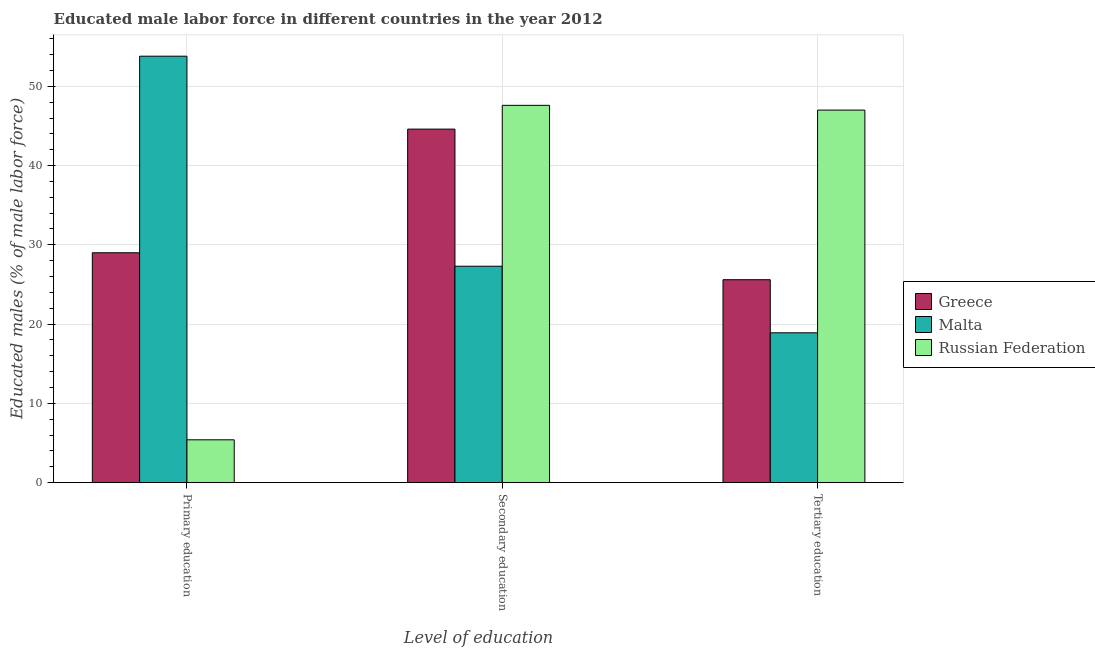How many different coloured bars are there?
Give a very brief answer. 3. How many groups of bars are there?
Keep it short and to the point. 3. How many bars are there on the 2nd tick from the right?
Ensure brevity in your answer.  3. What is the label of the 2nd group of bars from the left?
Ensure brevity in your answer.  Secondary education. What is the percentage of male labor force who received primary education in Russian Federation?
Offer a terse response. 5.4. Across all countries, what is the maximum percentage of male labor force who received primary education?
Make the answer very short. 53.8. Across all countries, what is the minimum percentage of male labor force who received tertiary education?
Ensure brevity in your answer.  18.9. In which country was the percentage of male labor force who received tertiary education maximum?
Ensure brevity in your answer.  Russian Federation. In which country was the percentage of male labor force who received tertiary education minimum?
Offer a terse response. Malta. What is the total percentage of male labor force who received secondary education in the graph?
Keep it short and to the point. 119.5. What is the difference between the percentage of male labor force who received secondary education in Greece and that in Malta?
Your answer should be compact. 17.3. What is the difference between the percentage of male labor force who received secondary education in Malta and the percentage of male labor force who received tertiary education in Russian Federation?
Your answer should be very brief. -19.7. What is the average percentage of male labor force who received secondary education per country?
Your answer should be very brief. 39.83. What is the difference between the percentage of male labor force who received secondary education and percentage of male labor force who received primary education in Russian Federation?
Offer a very short reply. 42.2. What is the ratio of the percentage of male labor force who received tertiary education in Malta to that in Russian Federation?
Give a very brief answer. 0.4. Is the percentage of male labor force who received secondary education in Malta less than that in Greece?
Provide a succinct answer. Yes. Is the difference between the percentage of male labor force who received tertiary education in Malta and Russian Federation greater than the difference between the percentage of male labor force who received secondary education in Malta and Russian Federation?
Offer a terse response. No. What is the difference between the highest and the second highest percentage of male labor force who received primary education?
Provide a succinct answer. 24.8. What is the difference between the highest and the lowest percentage of male labor force who received primary education?
Make the answer very short. 48.4. What does the 1st bar from the left in Tertiary education represents?
Your response must be concise. Greece. How many bars are there?
Give a very brief answer. 9. Are all the bars in the graph horizontal?
Ensure brevity in your answer.  No. What is the difference between two consecutive major ticks on the Y-axis?
Your response must be concise. 10. Does the graph contain any zero values?
Your response must be concise. No. Does the graph contain grids?
Your response must be concise. Yes. Where does the legend appear in the graph?
Your answer should be very brief. Center right. How many legend labels are there?
Provide a short and direct response. 3. What is the title of the graph?
Offer a terse response. Educated male labor force in different countries in the year 2012. Does "Mexico" appear as one of the legend labels in the graph?
Make the answer very short. No. What is the label or title of the X-axis?
Make the answer very short. Level of education. What is the label or title of the Y-axis?
Provide a succinct answer. Educated males (% of male labor force). What is the Educated males (% of male labor force) of Greece in Primary education?
Offer a terse response. 29. What is the Educated males (% of male labor force) in Malta in Primary education?
Your answer should be compact. 53.8. What is the Educated males (% of male labor force) of Russian Federation in Primary education?
Your answer should be compact. 5.4. What is the Educated males (% of male labor force) in Greece in Secondary education?
Keep it short and to the point. 44.6. What is the Educated males (% of male labor force) of Malta in Secondary education?
Offer a very short reply. 27.3. What is the Educated males (% of male labor force) in Russian Federation in Secondary education?
Offer a terse response. 47.6. What is the Educated males (% of male labor force) of Greece in Tertiary education?
Provide a succinct answer. 25.6. What is the Educated males (% of male labor force) in Malta in Tertiary education?
Offer a very short reply. 18.9. Across all Level of education, what is the maximum Educated males (% of male labor force) of Greece?
Keep it short and to the point. 44.6. Across all Level of education, what is the maximum Educated males (% of male labor force) of Malta?
Give a very brief answer. 53.8. Across all Level of education, what is the maximum Educated males (% of male labor force) in Russian Federation?
Ensure brevity in your answer.  47.6. Across all Level of education, what is the minimum Educated males (% of male labor force) in Greece?
Ensure brevity in your answer.  25.6. Across all Level of education, what is the minimum Educated males (% of male labor force) in Malta?
Offer a terse response. 18.9. Across all Level of education, what is the minimum Educated males (% of male labor force) in Russian Federation?
Provide a succinct answer. 5.4. What is the total Educated males (% of male labor force) of Greece in the graph?
Keep it short and to the point. 99.2. What is the difference between the Educated males (% of male labor force) of Greece in Primary education and that in Secondary education?
Ensure brevity in your answer.  -15.6. What is the difference between the Educated males (% of male labor force) of Russian Federation in Primary education and that in Secondary education?
Give a very brief answer. -42.2. What is the difference between the Educated males (% of male labor force) of Malta in Primary education and that in Tertiary education?
Offer a very short reply. 34.9. What is the difference between the Educated males (% of male labor force) of Russian Federation in Primary education and that in Tertiary education?
Keep it short and to the point. -41.6. What is the difference between the Educated males (% of male labor force) of Russian Federation in Secondary education and that in Tertiary education?
Offer a terse response. 0.6. What is the difference between the Educated males (% of male labor force) in Greece in Primary education and the Educated males (% of male labor force) in Malta in Secondary education?
Your answer should be compact. 1.7. What is the difference between the Educated males (% of male labor force) of Greece in Primary education and the Educated males (% of male labor force) of Russian Federation in Secondary education?
Your answer should be very brief. -18.6. What is the difference between the Educated males (% of male labor force) in Malta in Primary education and the Educated males (% of male labor force) in Russian Federation in Secondary education?
Your answer should be compact. 6.2. What is the difference between the Educated males (% of male labor force) of Greece in Primary education and the Educated males (% of male labor force) of Malta in Tertiary education?
Keep it short and to the point. 10.1. What is the difference between the Educated males (% of male labor force) of Greece in Secondary education and the Educated males (% of male labor force) of Malta in Tertiary education?
Make the answer very short. 25.7. What is the difference between the Educated males (% of male labor force) of Malta in Secondary education and the Educated males (% of male labor force) of Russian Federation in Tertiary education?
Provide a succinct answer. -19.7. What is the average Educated males (% of male labor force) of Greece per Level of education?
Ensure brevity in your answer.  33.07. What is the average Educated males (% of male labor force) in Malta per Level of education?
Your response must be concise. 33.33. What is the average Educated males (% of male labor force) in Russian Federation per Level of education?
Make the answer very short. 33.33. What is the difference between the Educated males (% of male labor force) in Greece and Educated males (% of male labor force) in Malta in Primary education?
Offer a terse response. -24.8. What is the difference between the Educated males (% of male labor force) in Greece and Educated males (% of male labor force) in Russian Federation in Primary education?
Provide a short and direct response. 23.6. What is the difference between the Educated males (% of male labor force) in Malta and Educated males (% of male labor force) in Russian Federation in Primary education?
Your answer should be very brief. 48.4. What is the difference between the Educated males (% of male labor force) of Malta and Educated males (% of male labor force) of Russian Federation in Secondary education?
Your answer should be compact. -20.3. What is the difference between the Educated males (% of male labor force) of Greece and Educated males (% of male labor force) of Malta in Tertiary education?
Make the answer very short. 6.7. What is the difference between the Educated males (% of male labor force) in Greece and Educated males (% of male labor force) in Russian Federation in Tertiary education?
Keep it short and to the point. -21.4. What is the difference between the Educated males (% of male labor force) of Malta and Educated males (% of male labor force) of Russian Federation in Tertiary education?
Ensure brevity in your answer.  -28.1. What is the ratio of the Educated males (% of male labor force) in Greece in Primary education to that in Secondary education?
Your answer should be very brief. 0.65. What is the ratio of the Educated males (% of male labor force) in Malta in Primary education to that in Secondary education?
Make the answer very short. 1.97. What is the ratio of the Educated males (% of male labor force) in Russian Federation in Primary education to that in Secondary education?
Your response must be concise. 0.11. What is the ratio of the Educated males (% of male labor force) in Greece in Primary education to that in Tertiary education?
Provide a short and direct response. 1.13. What is the ratio of the Educated males (% of male labor force) in Malta in Primary education to that in Tertiary education?
Offer a very short reply. 2.85. What is the ratio of the Educated males (% of male labor force) of Russian Federation in Primary education to that in Tertiary education?
Your answer should be very brief. 0.11. What is the ratio of the Educated males (% of male labor force) of Greece in Secondary education to that in Tertiary education?
Provide a succinct answer. 1.74. What is the ratio of the Educated males (% of male labor force) in Malta in Secondary education to that in Tertiary education?
Keep it short and to the point. 1.44. What is the ratio of the Educated males (% of male labor force) in Russian Federation in Secondary education to that in Tertiary education?
Provide a succinct answer. 1.01. What is the difference between the highest and the second highest Educated males (% of male labor force) in Russian Federation?
Offer a terse response. 0.6. What is the difference between the highest and the lowest Educated males (% of male labor force) of Greece?
Provide a succinct answer. 19. What is the difference between the highest and the lowest Educated males (% of male labor force) in Malta?
Keep it short and to the point. 34.9. What is the difference between the highest and the lowest Educated males (% of male labor force) in Russian Federation?
Offer a terse response. 42.2. 